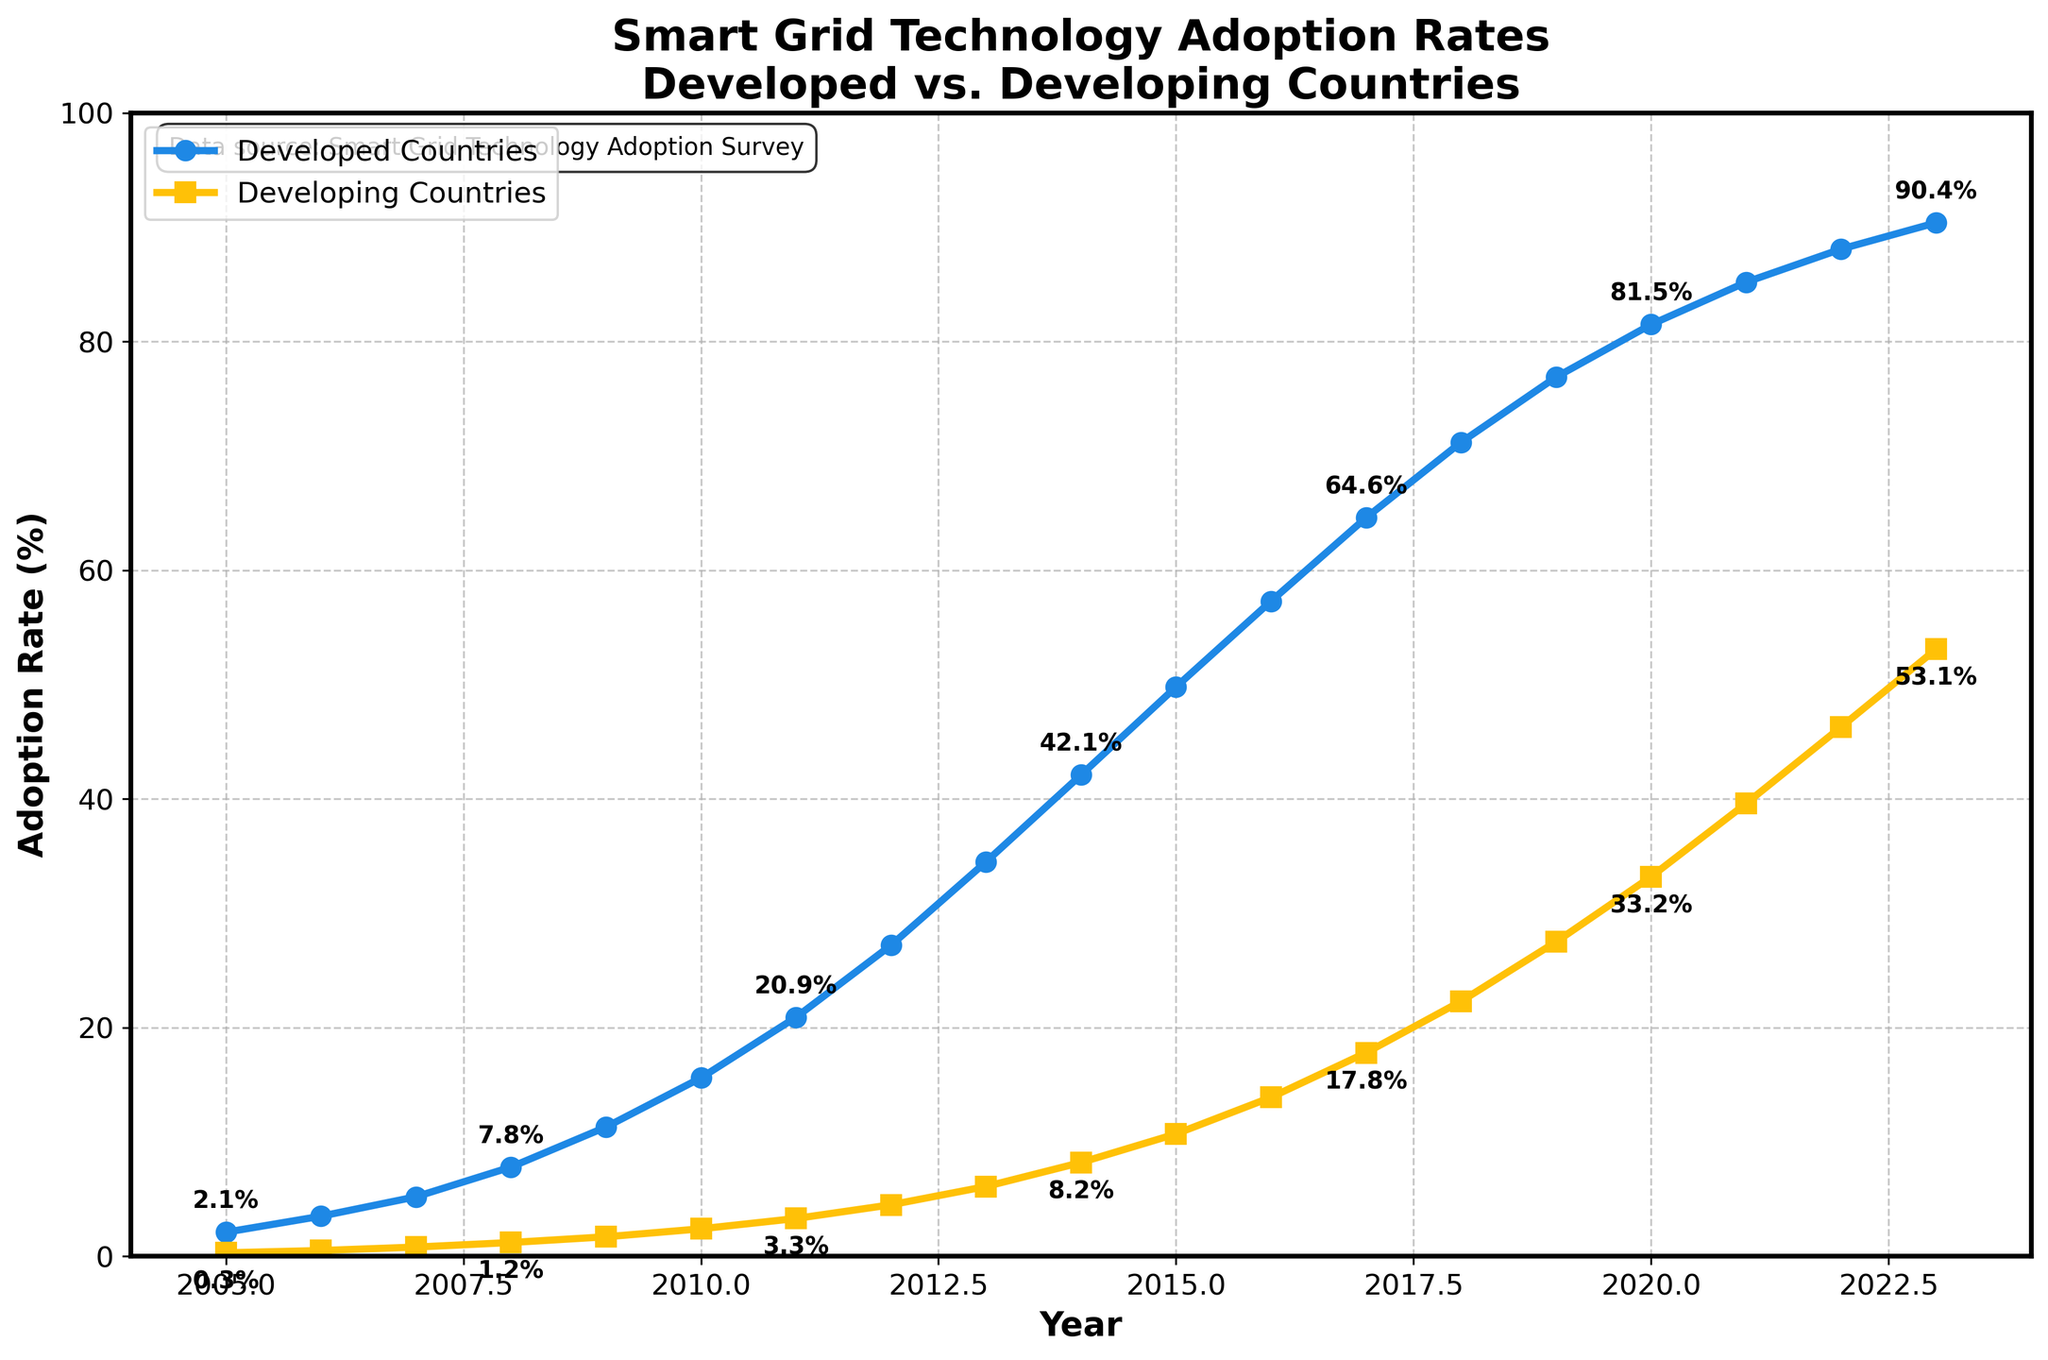What is the adoption rate of smart grid technologies in developed countries in 2020? Look at the line for developed countries and find the value corresponding to the year 2020. The marker and label indicate the adoption rate.
Answer: 81.5% How has the adoption rate changed in developing countries from 2010 to 2015? Find the adoption rates for developing countries for both years. For 2010, the adoption rate is 2.4%, and for 2015, it is 10.7%. Calculate the difference: 10.7% - 2.4% = 8.3%.
Answer: Increased by 8.3% Which year had the same adoption rate of 33.2% in developing countries? Find the point on the developing countries’ line where the adoption rate is 33.2%. The corresponding year on the x-axis is 2020.
Answer: 2020 What is the difference in adoption rates between developed and developing countries in 2009? Find the adoption rates for both developed and developing countries in 2009. For developed, it’s 11.3%, and for developing, it’s 1.7%. Calculate the difference: 11.3% - 1.7% = 9.6%.
Answer: 9.6% How much did the adoption rate in developed countries increase from 2011 to 2015? Find the adoption rates for developed countries in 2011 and 2015. For 2011, it’s 20.9%, and for 2015, it’s 49.8%. Calculate the increase: 49.8% - 20.9% = 28.9%.
Answer: 28.9% Which group had a higher adoption rate in 2013 and by how much? Compare the adoption rates for developed and developing countries in 2013. Developed countries had 34.5%, and developing countries had 6.1%. Calculate the difference: 34.5% - 6.1% = 28.4%.
Answer: Developed by 28.4% What is the average adoption rate for developing countries from 2005 to 2010? Find the adoption rates for developing countries from 2005 to 2010: 0.3%, 0.5%, 0.8%, 1.2%, 1.7%, and 2.4%. Calculate the sum: 0.3 + 0.5 + 0.8 + 1.2 + 1.7 + 2.4 = 6.9%. Then calculate the average: 6.9 / 6 = 1.15%.
Answer: 1.15% Did the adoption rate in developed countries ever decrease? Observe the trend of the developed countries' line. It consistently increases throughout the years.
Answer: No What was the approximate rate of growth in adoption rates for developing countries between 2018 and 2020? Find the adoption rates for developing countries in 2018 and 2020: 22.3% and 33.2%. Calculate the difference: 33.2% - 22.3% = 10.9%. Divide by the number of years (2): 10.9 / 2 = 5.45% per year.
Answer: 5.45% per year In which year did the adoption rate in developed countries surpass 70%? Observe the developed countries’ line and look for the point where it first exceeds 70%. This occurs in 2018.
Answer: 2018 